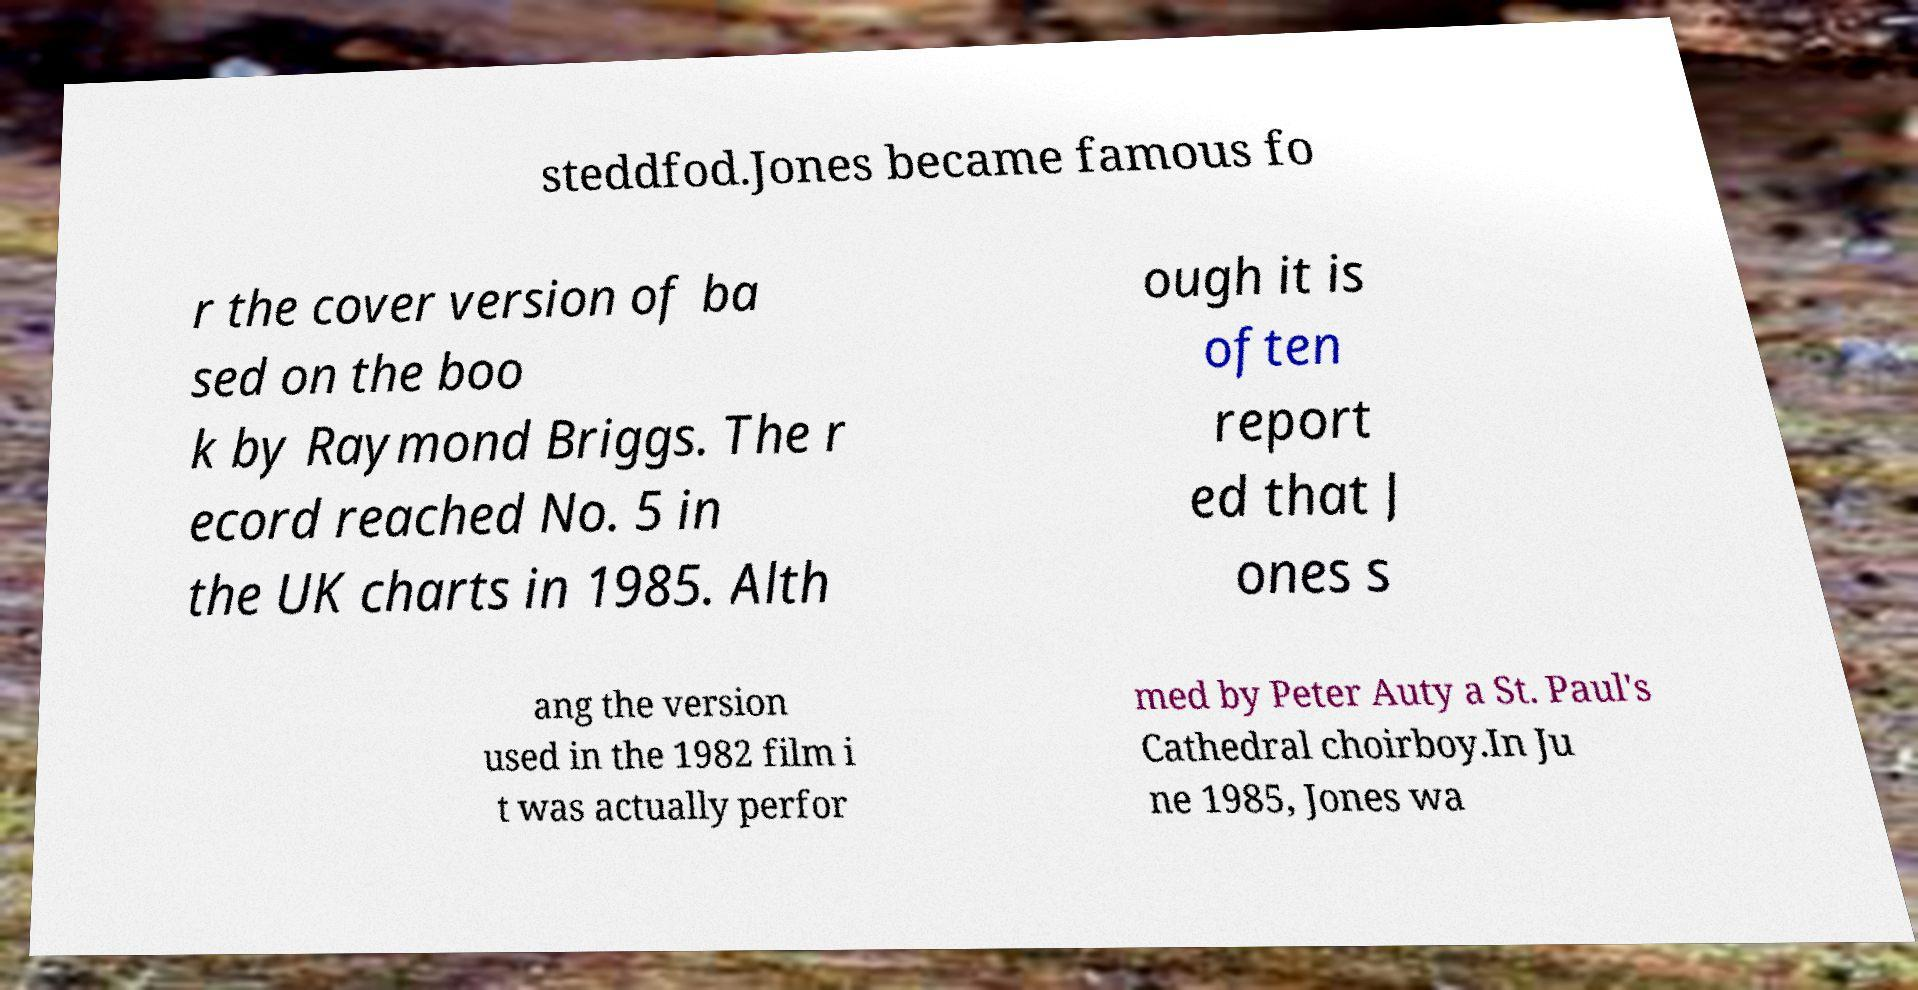Can you accurately transcribe the text from the provided image for me? steddfod.Jones became famous fo r the cover version of ba sed on the boo k by Raymond Briggs. The r ecord reached No. 5 in the UK charts in 1985. Alth ough it is often report ed that J ones s ang the version used in the 1982 film i t was actually perfor med by Peter Auty a St. Paul's Cathedral choirboy.In Ju ne 1985, Jones wa 